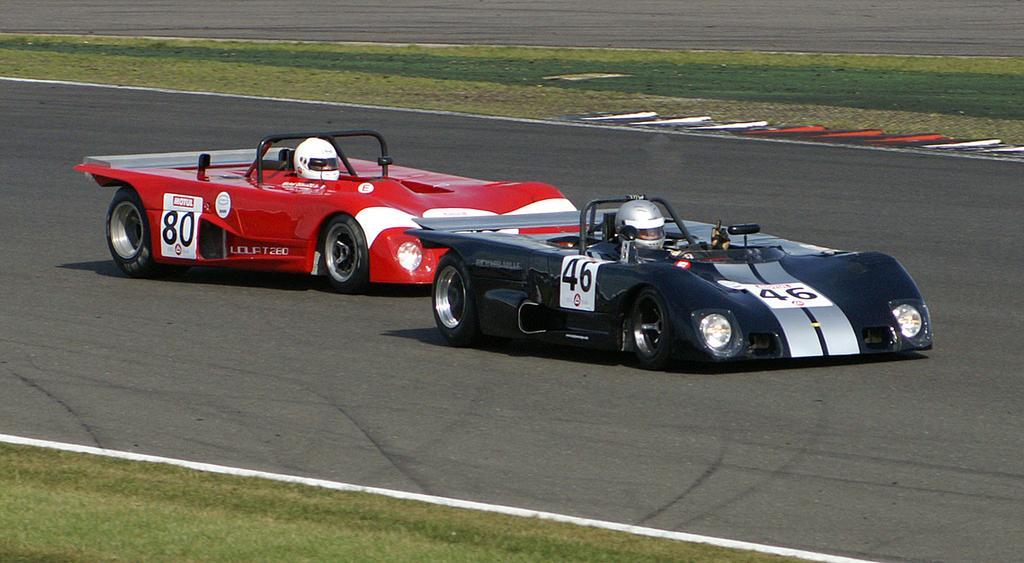In one or two sentences, can you explain what this image depicts? In this image we can see two people are sitting in two different cars which is on the road. One car is in black color and the other one is in red color. To the both sides of the road, grassy lands are there. 